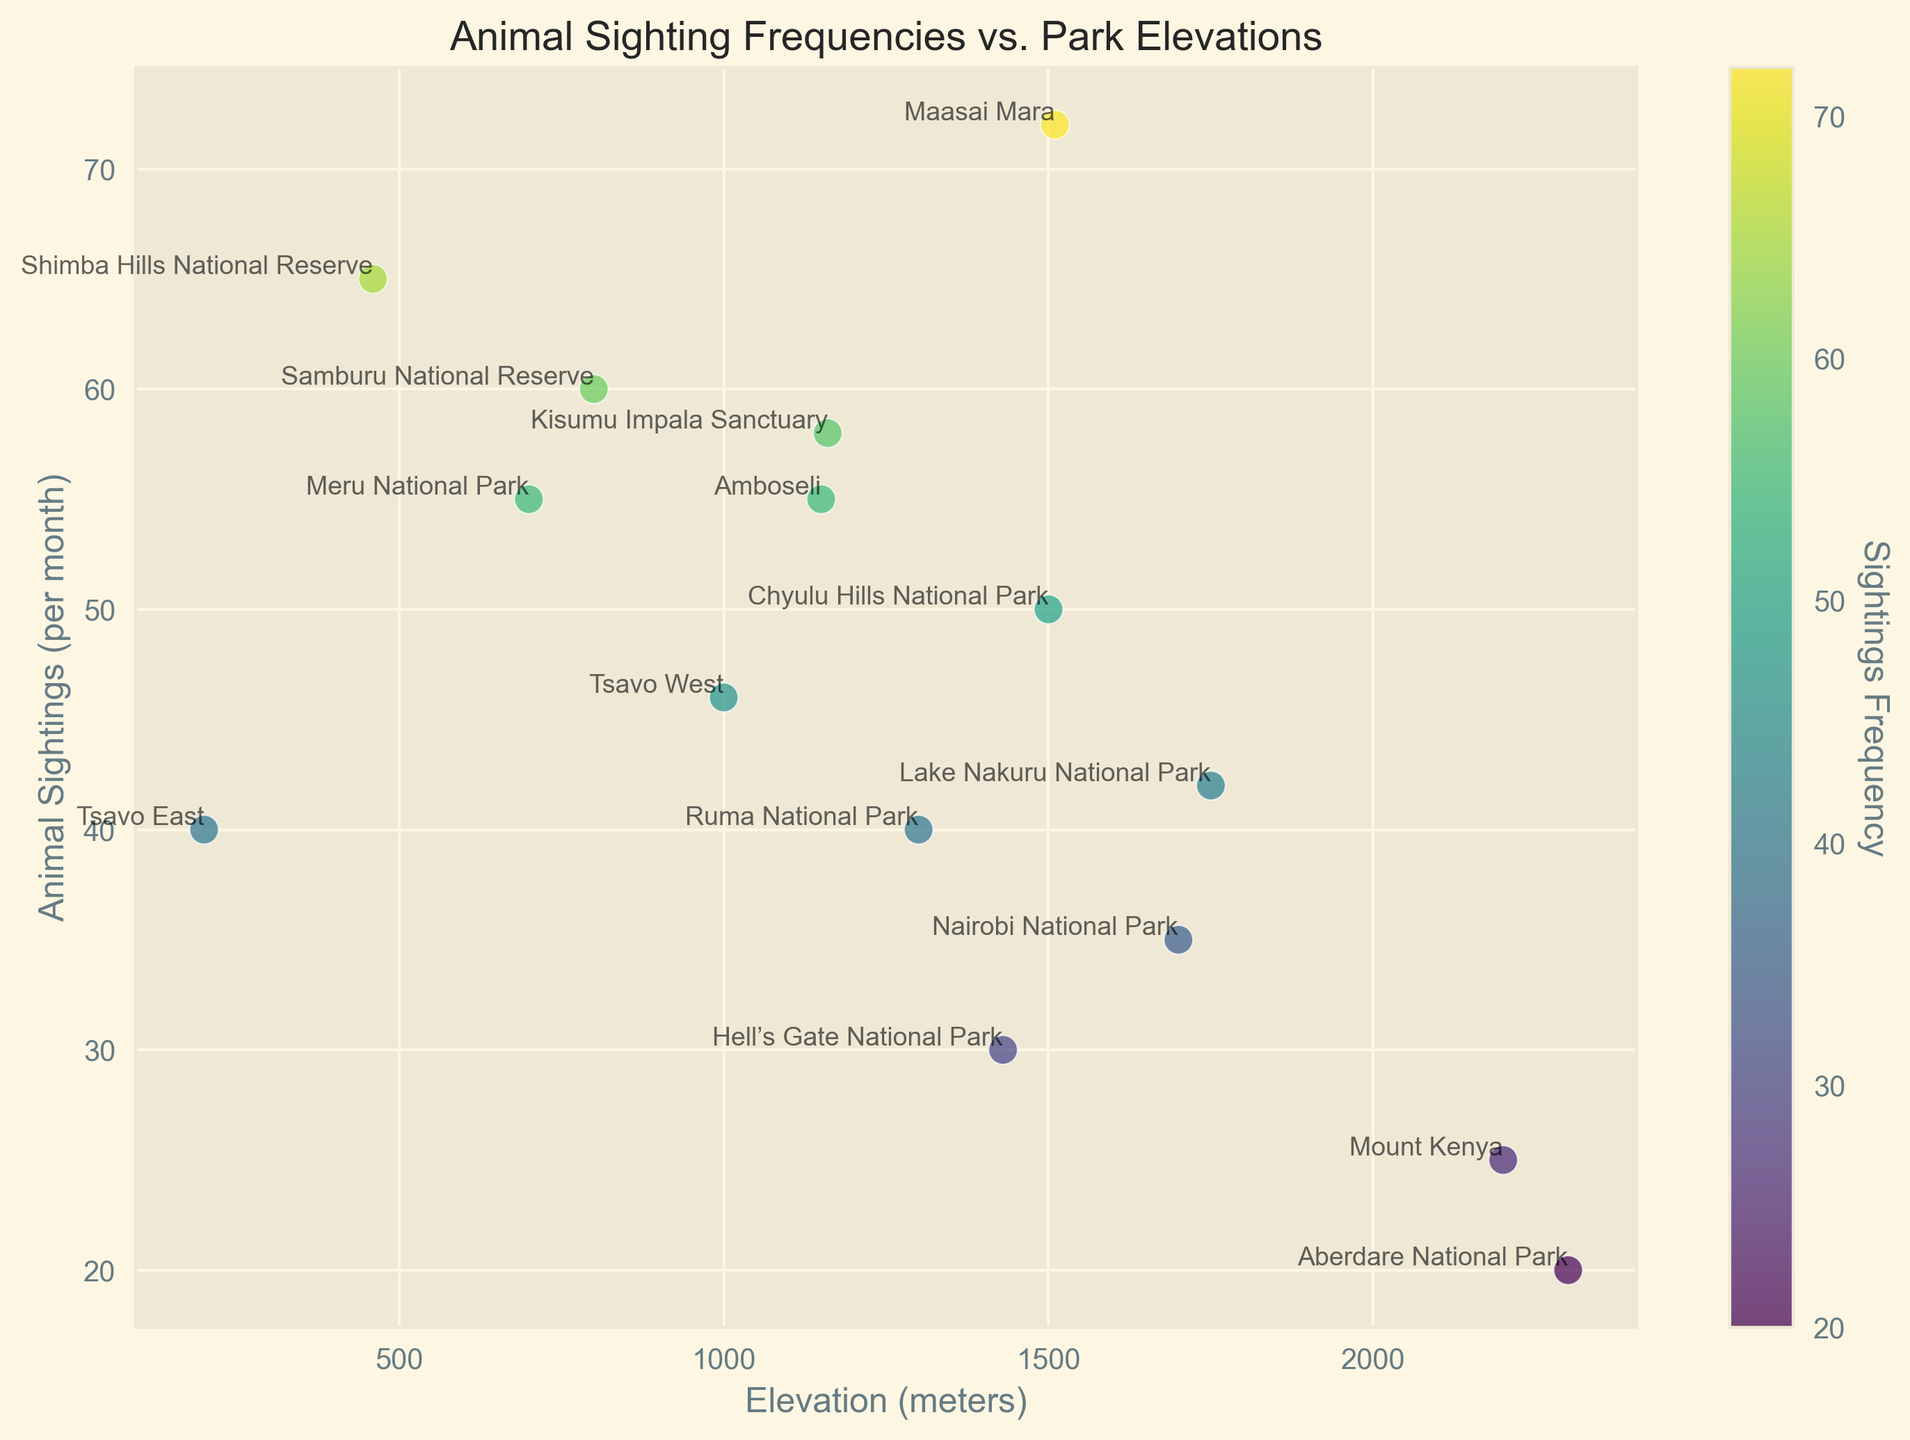What is the highest number of animal sightings reported and at which elevation is it found? The highest number of animal sightings reported is 72, which occurs at the park with an elevation of 1510 meters. Specifically, in Maasai Mara.
Answer: 72 sightings at 1510 meters Which park reports the lowest number of animal sightings and what is its elevation? The park with the lowest number of animal sightings is Aberdare National Park, with 20 sightings. This park has an elevation of 2300 meters.
Answer: 20 sightings at 2300 meters Are there more parks with sightings higher than 50 at elevations below or above 1000 meters? The parks with sightings higher than 50 are Amboseli, Samburu National Reserve, Meru National Park, Shimba Hills National Reserve, and Kisumu Impala Sanctuary. Among these, Amboseli, Meru National Park, and Shimba Hills National Reserve are below 1000 meters. Samburu National Reserve and Kisumu Impala Sanctuary are also below 1000 meters. Therefore, more parks with sightings higher than 50 are below 1000 meters.
Answer: Below 1000 meters What is the average number of animal sightings per month for parks elevated above 1500 meters? Parks elevated above 1500 meters are Maasai Mara, Nairobi National Park, Mount Kenya, Aberdare National Park, and Lake Nakuru National Park. Their sightings are 72, 35, 25, 20, and 42 respectively. Calculate the average by summing these values and dividing by the number of parks: (72 + 35 + 25 + 20 + 42) = 58.8.
Answer: 38.8 Which two parks at the same elevation have the most different numbers of animal sightings? Chyulu Hills National Park and Maasai Mara are both elevated at 1500 meters but differ significantly in animal sightings: Chyulu Hills National Park has 50 sightings, while Maasai Mara has 72 sightings, showing a difference of 22 sightings.
Answer: Chyulu Hills National Park and Maasai Mara Is there a correlation between elevation and animal sightings? Observing the scatter plot, there is a general negative trend showing that as the elevation increases, the number of animal sightings tends to decrease.
Answer: Negative correlation Which park has the closest number of sightings to the median number of sightings, and what is the value? The median is calculated by ordering the number of sightings and finding the middle value. Arranging the sightings: 20, 25, 30, 35, 40, 40, 42, 46, 50, 55, 55, 58, 60, 65, 72. The median value, being the 8th value, is 46. Tsavo West, which has 46 sightings, is closest to this median value.
Answer: Tsavo West with 46 sightings Are there any parks with the same number of animal sightings but different elevations? Amboseli and Meru National Park both report 55 animal sightings. Amboseli is at 1150 meters, while Meru National Park is at 700 meters.
Answer: Amboseli and Meru National Park What is the sighting frequency difference between the highest elevated park and the lowest elevated park? The highest elevated park is Aberdare National Park at 2300 meters with 20 sightings. The lowest elevated park is Tsavo East at 200 meters with 40 sightings. The difference is calculated as 40 - 20 = 20.
Answer: 20 sightings 